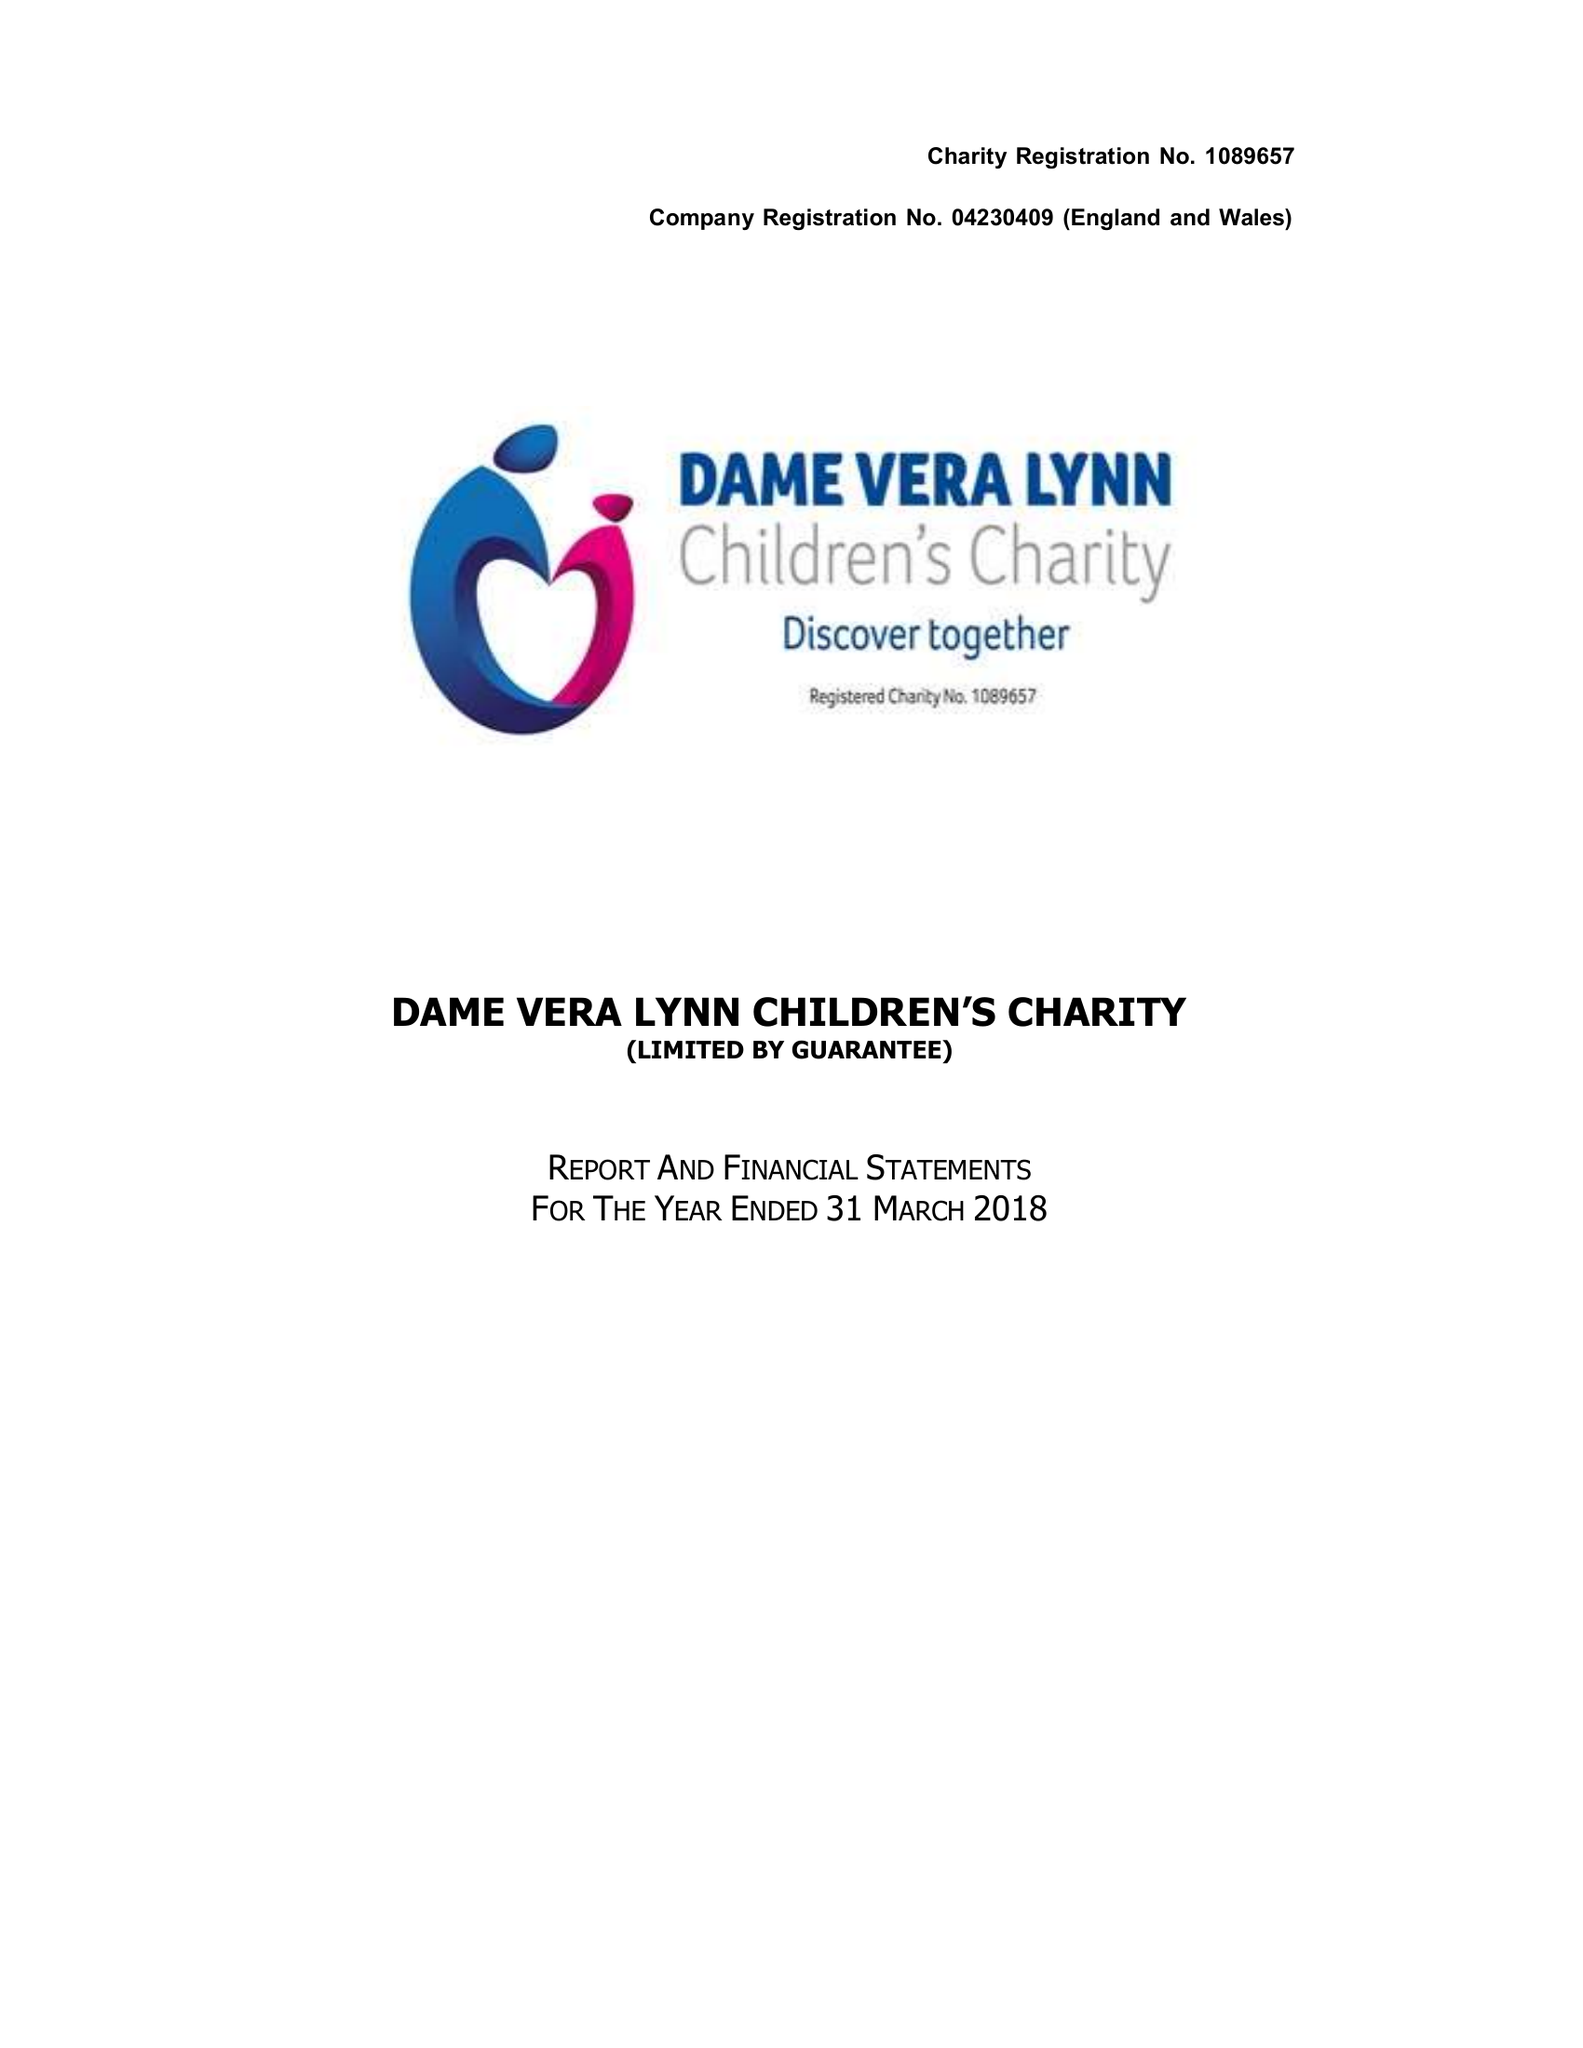What is the value for the spending_annually_in_british_pounds?
Answer the question using a single word or phrase. 334010.00 